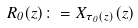Convert formula to latex. <formula><loc_0><loc_0><loc_500><loc_500>R _ { 0 } ( z ) \colon = X _ { \tau _ { 0 } ( z ) } ( z )</formula> 